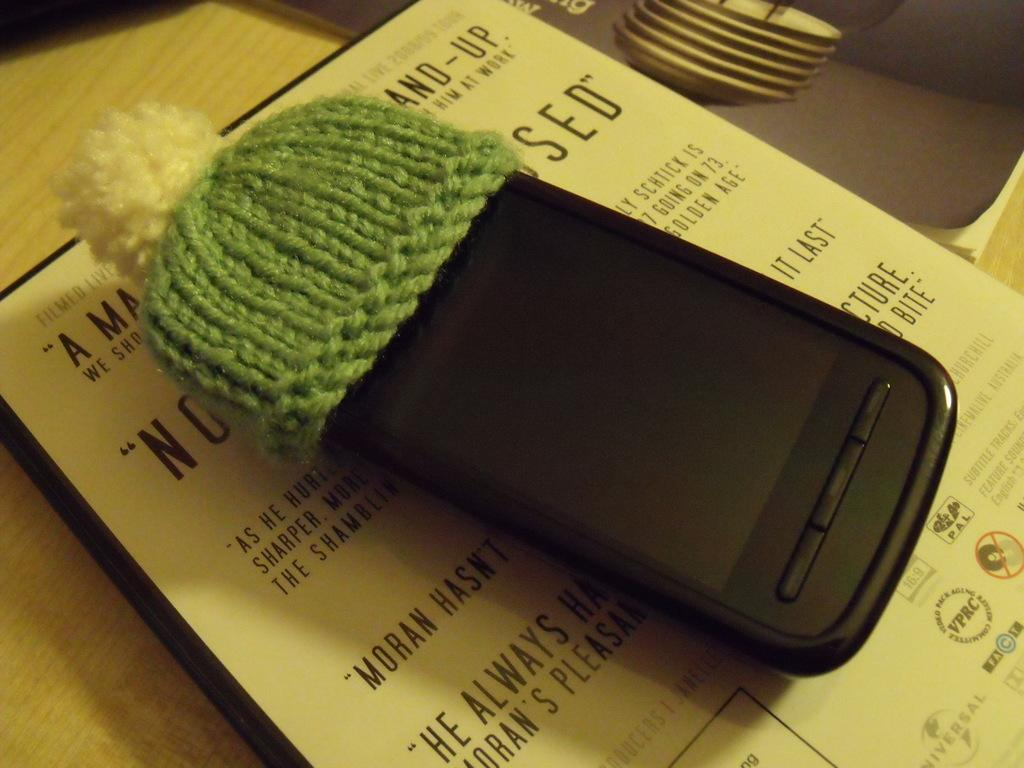What electronic device is visible in the image? There is a mobile phone in the image. What type of clothing accessory is present in the image? There is a cap made up of wool in the image. How is the cap being used in the image? The cap is on the mobile phone. What type of reading material is in the image? There is a book in the image. On what surface is the book placed? The book is on a wooden board. What type of metal is used to construct the office in the image? There is no office present in the image; it features a mobile phone, a wool cap, a book, and a wooden board. 